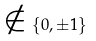<formula> <loc_0><loc_0><loc_500><loc_500>\notin \{ 0 , \pm 1 \}</formula> 